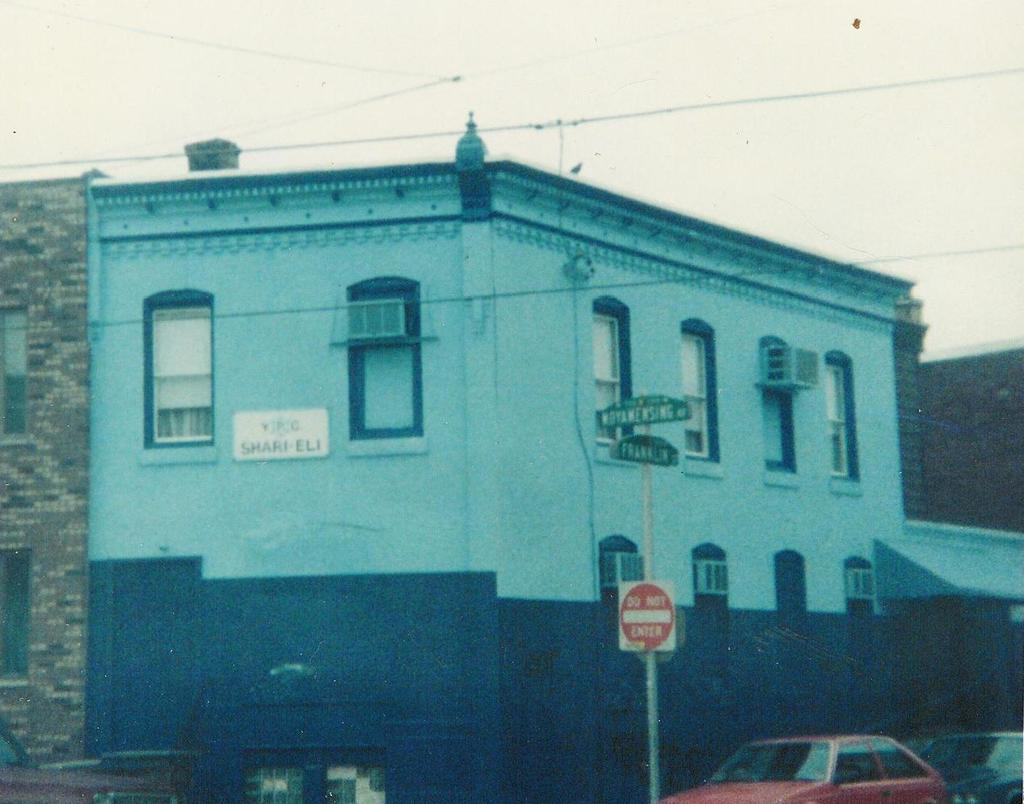<image>
Give a short and clear explanation of the subsequent image. A blue building has a sign that says Shari Eli. 